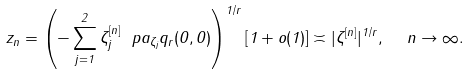<formula> <loc_0><loc_0><loc_500><loc_500>z _ { n } = \left ( - \sum _ { j = 1 } ^ { 2 } \zeta _ { j } ^ { [ n ] } \ p a _ { \zeta _ { j } } q _ { r } ( 0 , 0 ) \right ) ^ { 1 / r } [ 1 + o ( 1 ) ] \asymp | \zeta ^ { [ n ] } | ^ { 1 / r } , \ \ n \to \infty .</formula> 